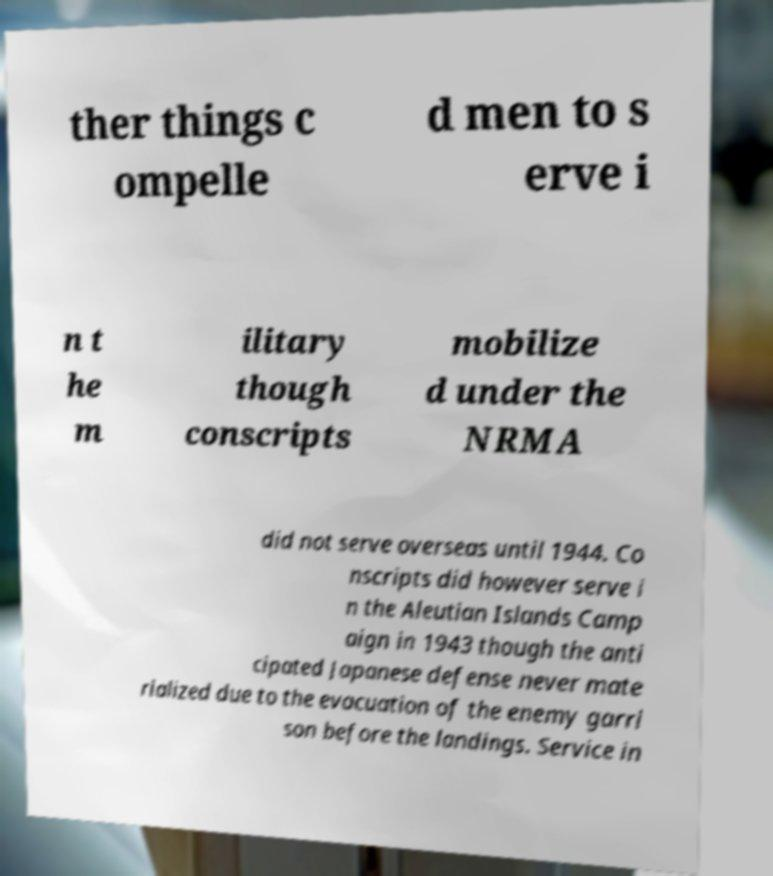Please read and relay the text visible in this image. What does it say? ther things c ompelle d men to s erve i n t he m ilitary though conscripts mobilize d under the NRMA did not serve overseas until 1944. Co nscripts did however serve i n the Aleutian Islands Camp aign in 1943 though the anti cipated Japanese defense never mate rialized due to the evacuation of the enemy garri son before the landings. Service in 